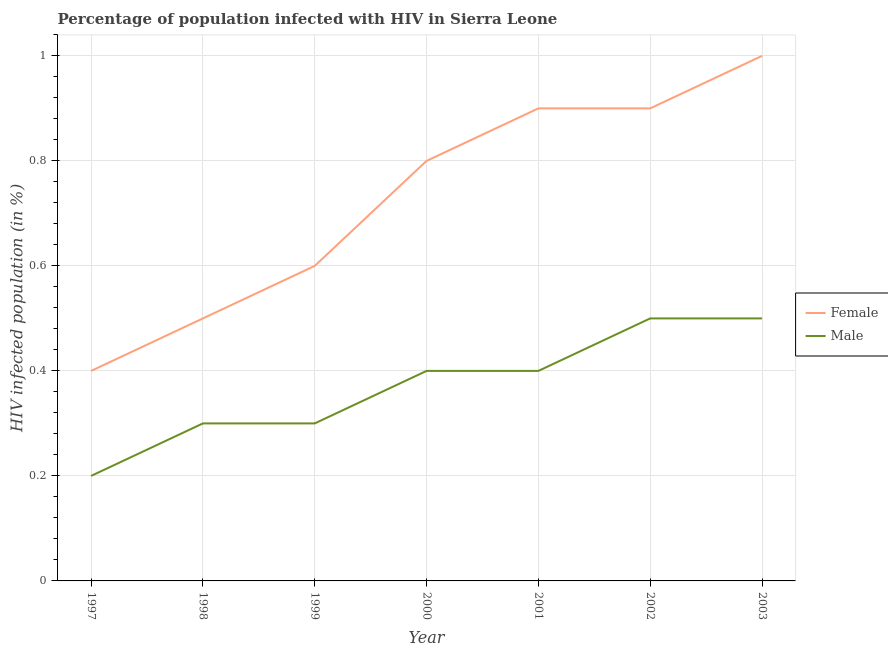Is the number of lines equal to the number of legend labels?
Provide a short and direct response. Yes. Across all years, what is the maximum percentage of males who are infected with hiv?
Your answer should be compact. 0.5. Across all years, what is the minimum percentage of females who are infected with hiv?
Ensure brevity in your answer.  0.4. In which year was the percentage of females who are infected with hiv maximum?
Your response must be concise. 2003. In which year was the percentage of males who are infected with hiv minimum?
Your answer should be very brief. 1997. What is the difference between the percentage of males who are infected with hiv in 1998 and that in 2002?
Keep it short and to the point. -0.2. What is the difference between the percentage of males who are infected with hiv in 1997 and the percentage of females who are infected with hiv in 2001?
Ensure brevity in your answer.  -0.7. What is the average percentage of males who are infected with hiv per year?
Make the answer very short. 0.37. In the year 1998, what is the difference between the percentage of males who are infected with hiv and percentage of females who are infected with hiv?
Your answer should be very brief. -0.2. In how many years, is the percentage of males who are infected with hiv greater than 0.08 %?
Offer a terse response. 7. Is the difference between the percentage of males who are infected with hiv in 1998 and 2001 greater than the difference between the percentage of females who are infected with hiv in 1998 and 2001?
Your answer should be compact. Yes. What is the difference between the highest and the second highest percentage of females who are infected with hiv?
Ensure brevity in your answer.  0.1. What is the difference between the highest and the lowest percentage of males who are infected with hiv?
Keep it short and to the point. 0.3. Is the sum of the percentage of females who are infected with hiv in 1997 and 2002 greater than the maximum percentage of males who are infected with hiv across all years?
Make the answer very short. Yes. How many years are there in the graph?
Provide a succinct answer. 7. What is the difference between two consecutive major ticks on the Y-axis?
Offer a very short reply. 0.2. Does the graph contain grids?
Provide a succinct answer. Yes. Where does the legend appear in the graph?
Offer a very short reply. Center right. How many legend labels are there?
Offer a terse response. 2. What is the title of the graph?
Provide a short and direct response. Percentage of population infected with HIV in Sierra Leone. What is the label or title of the Y-axis?
Ensure brevity in your answer.  HIV infected population (in %). What is the HIV infected population (in %) in Male in 1997?
Ensure brevity in your answer.  0.2. What is the HIV infected population (in %) of Male in 1998?
Provide a succinct answer. 0.3. What is the HIV infected population (in %) of Female in 1999?
Your answer should be very brief. 0.6. What is the HIV infected population (in %) of Male in 1999?
Provide a succinct answer. 0.3. What is the HIV infected population (in %) in Male in 2000?
Keep it short and to the point. 0.4. What is the HIV infected population (in %) in Female in 2001?
Offer a very short reply. 0.9. What is the HIV infected population (in %) in Female in 2003?
Provide a short and direct response. 1. What is the HIV infected population (in %) in Male in 2003?
Your answer should be very brief. 0.5. Across all years, what is the maximum HIV infected population (in %) of Female?
Your response must be concise. 1. Across all years, what is the maximum HIV infected population (in %) in Male?
Ensure brevity in your answer.  0.5. Across all years, what is the minimum HIV infected population (in %) in Male?
Keep it short and to the point. 0.2. What is the total HIV infected population (in %) in Female in the graph?
Give a very brief answer. 5.1. What is the difference between the HIV infected population (in %) of Female in 1997 and that in 1998?
Provide a succinct answer. -0.1. What is the difference between the HIV infected population (in %) of Male in 1997 and that in 1998?
Ensure brevity in your answer.  -0.1. What is the difference between the HIV infected population (in %) of Female in 1997 and that in 1999?
Offer a terse response. -0.2. What is the difference between the HIV infected population (in %) of Female in 1997 and that in 2002?
Give a very brief answer. -0.5. What is the difference between the HIV infected population (in %) of Male in 1997 and that in 2002?
Offer a terse response. -0.3. What is the difference between the HIV infected population (in %) in Female in 1997 and that in 2003?
Offer a very short reply. -0.6. What is the difference between the HIV infected population (in %) in Male in 1998 and that in 1999?
Your response must be concise. 0. What is the difference between the HIV infected population (in %) of Female in 1998 and that in 2000?
Ensure brevity in your answer.  -0.3. What is the difference between the HIV infected population (in %) in Male in 1998 and that in 2000?
Offer a terse response. -0.1. What is the difference between the HIV infected population (in %) of Male in 1998 and that in 2002?
Your answer should be very brief. -0.2. What is the difference between the HIV infected population (in %) of Female in 1999 and that in 2000?
Offer a terse response. -0.2. What is the difference between the HIV infected population (in %) in Female in 1999 and that in 2001?
Ensure brevity in your answer.  -0.3. What is the difference between the HIV infected population (in %) of Male in 1999 and that in 2001?
Provide a short and direct response. -0.1. What is the difference between the HIV infected population (in %) in Male in 1999 and that in 2002?
Keep it short and to the point. -0.2. What is the difference between the HIV infected population (in %) in Male in 2000 and that in 2001?
Your answer should be compact. 0. What is the difference between the HIV infected population (in %) in Male in 2000 and that in 2002?
Give a very brief answer. -0.1. What is the difference between the HIV infected population (in %) in Female in 2000 and that in 2003?
Make the answer very short. -0.2. What is the difference between the HIV infected population (in %) in Male in 2000 and that in 2003?
Keep it short and to the point. -0.1. What is the difference between the HIV infected population (in %) in Female in 2001 and that in 2003?
Provide a short and direct response. -0.1. What is the difference between the HIV infected population (in %) in Male in 2001 and that in 2003?
Offer a terse response. -0.1. What is the difference between the HIV infected population (in %) of Female in 2002 and that in 2003?
Ensure brevity in your answer.  -0.1. What is the difference between the HIV infected population (in %) in Female in 1997 and the HIV infected population (in %) in Male in 1998?
Provide a succinct answer. 0.1. What is the difference between the HIV infected population (in %) in Female in 1997 and the HIV infected population (in %) in Male in 2001?
Keep it short and to the point. 0. What is the difference between the HIV infected population (in %) of Female in 1998 and the HIV infected population (in %) of Male in 2000?
Offer a terse response. 0.1. What is the difference between the HIV infected population (in %) in Female in 1998 and the HIV infected population (in %) in Male in 2001?
Ensure brevity in your answer.  0.1. What is the difference between the HIV infected population (in %) in Female in 1998 and the HIV infected population (in %) in Male in 2002?
Make the answer very short. 0. What is the difference between the HIV infected population (in %) in Female in 1998 and the HIV infected population (in %) in Male in 2003?
Give a very brief answer. 0. What is the difference between the HIV infected population (in %) of Female in 1999 and the HIV infected population (in %) of Male in 2000?
Keep it short and to the point. 0.2. What is the difference between the HIV infected population (in %) in Female in 1999 and the HIV infected population (in %) in Male in 2002?
Give a very brief answer. 0.1. What is the difference between the HIV infected population (in %) of Female in 2000 and the HIV infected population (in %) of Male in 2003?
Provide a succinct answer. 0.3. What is the difference between the HIV infected population (in %) in Female in 2001 and the HIV infected population (in %) in Male in 2002?
Offer a terse response. 0.4. What is the difference between the HIV infected population (in %) of Female in 2001 and the HIV infected population (in %) of Male in 2003?
Make the answer very short. 0.4. What is the difference between the HIV infected population (in %) in Female in 2002 and the HIV infected population (in %) in Male in 2003?
Ensure brevity in your answer.  0.4. What is the average HIV infected population (in %) in Female per year?
Provide a succinct answer. 0.73. What is the average HIV infected population (in %) of Male per year?
Offer a terse response. 0.37. In the year 1999, what is the difference between the HIV infected population (in %) of Female and HIV infected population (in %) of Male?
Your response must be concise. 0.3. In the year 2000, what is the difference between the HIV infected population (in %) of Female and HIV infected population (in %) of Male?
Your response must be concise. 0.4. In the year 2002, what is the difference between the HIV infected population (in %) of Female and HIV infected population (in %) of Male?
Your response must be concise. 0.4. In the year 2003, what is the difference between the HIV infected population (in %) of Female and HIV infected population (in %) of Male?
Make the answer very short. 0.5. What is the ratio of the HIV infected population (in %) of Male in 1997 to that in 1998?
Offer a very short reply. 0.67. What is the ratio of the HIV infected population (in %) in Female in 1997 to that in 1999?
Offer a terse response. 0.67. What is the ratio of the HIV infected population (in %) in Male in 1997 to that in 2000?
Offer a very short reply. 0.5. What is the ratio of the HIV infected population (in %) of Female in 1997 to that in 2001?
Offer a terse response. 0.44. What is the ratio of the HIV infected population (in %) of Male in 1997 to that in 2001?
Make the answer very short. 0.5. What is the ratio of the HIV infected population (in %) of Female in 1997 to that in 2002?
Offer a very short reply. 0.44. What is the ratio of the HIV infected population (in %) in Female in 1997 to that in 2003?
Offer a very short reply. 0.4. What is the ratio of the HIV infected population (in %) in Female in 1998 to that in 1999?
Provide a succinct answer. 0.83. What is the ratio of the HIV infected population (in %) of Female in 1998 to that in 2001?
Your answer should be compact. 0.56. What is the ratio of the HIV infected population (in %) in Female in 1998 to that in 2002?
Make the answer very short. 0.56. What is the ratio of the HIV infected population (in %) of Male in 1998 to that in 2002?
Provide a succinct answer. 0.6. What is the ratio of the HIV infected population (in %) of Female in 1998 to that in 2003?
Provide a short and direct response. 0.5. What is the ratio of the HIV infected population (in %) of Female in 1999 to that in 2000?
Your answer should be very brief. 0.75. What is the ratio of the HIV infected population (in %) of Female in 1999 to that in 2003?
Provide a succinct answer. 0.6. What is the ratio of the HIV infected population (in %) in Male in 1999 to that in 2003?
Provide a succinct answer. 0.6. What is the ratio of the HIV infected population (in %) in Female in 2000 to that in 2002?
Make the answer very short. 0.89. What is the ratio of the HIV infected population (in %) in Male in 2001 to that in 2002?
Your answer should be compact. 0.8. What is the ratio of the HIV infected population (in %) of Female in 2001 to that in 2003?
Provide a short and direct response. 0.9. What is the ratio of the HIV infected population (in %) of Male in 2001 to that in 2003?
Give a very brief answer. 0.8. What is the difference between the highest and the second highest HIV infected population (in %) of Female?
Keep it short and to the point. 0.1. What is the difference between the highest and the second highest HIV infected population (in %) of Male?
Make the answer very short. 0. What is the difference between the highest and the lowest HIV infected population (in %) in Male?
Your answer should be very brief. 0.3. 